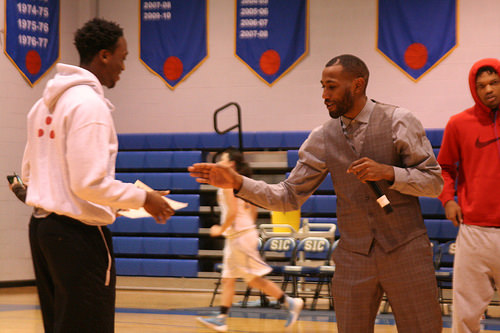<image>
Can you confirm if the man is in front of the girl? Yes. The man is positioned in front of the girl, appearing closer to the camera viewpoint. 